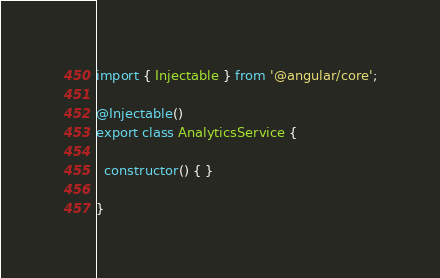Convert code to text. <code><loc_0><loc_0><loc_500><loc_500><_TypeScript_>import { Injectable } from '@angular/core';

@Injectable()
export class AnalyticsService {

  constructor() { }

}
</code> 